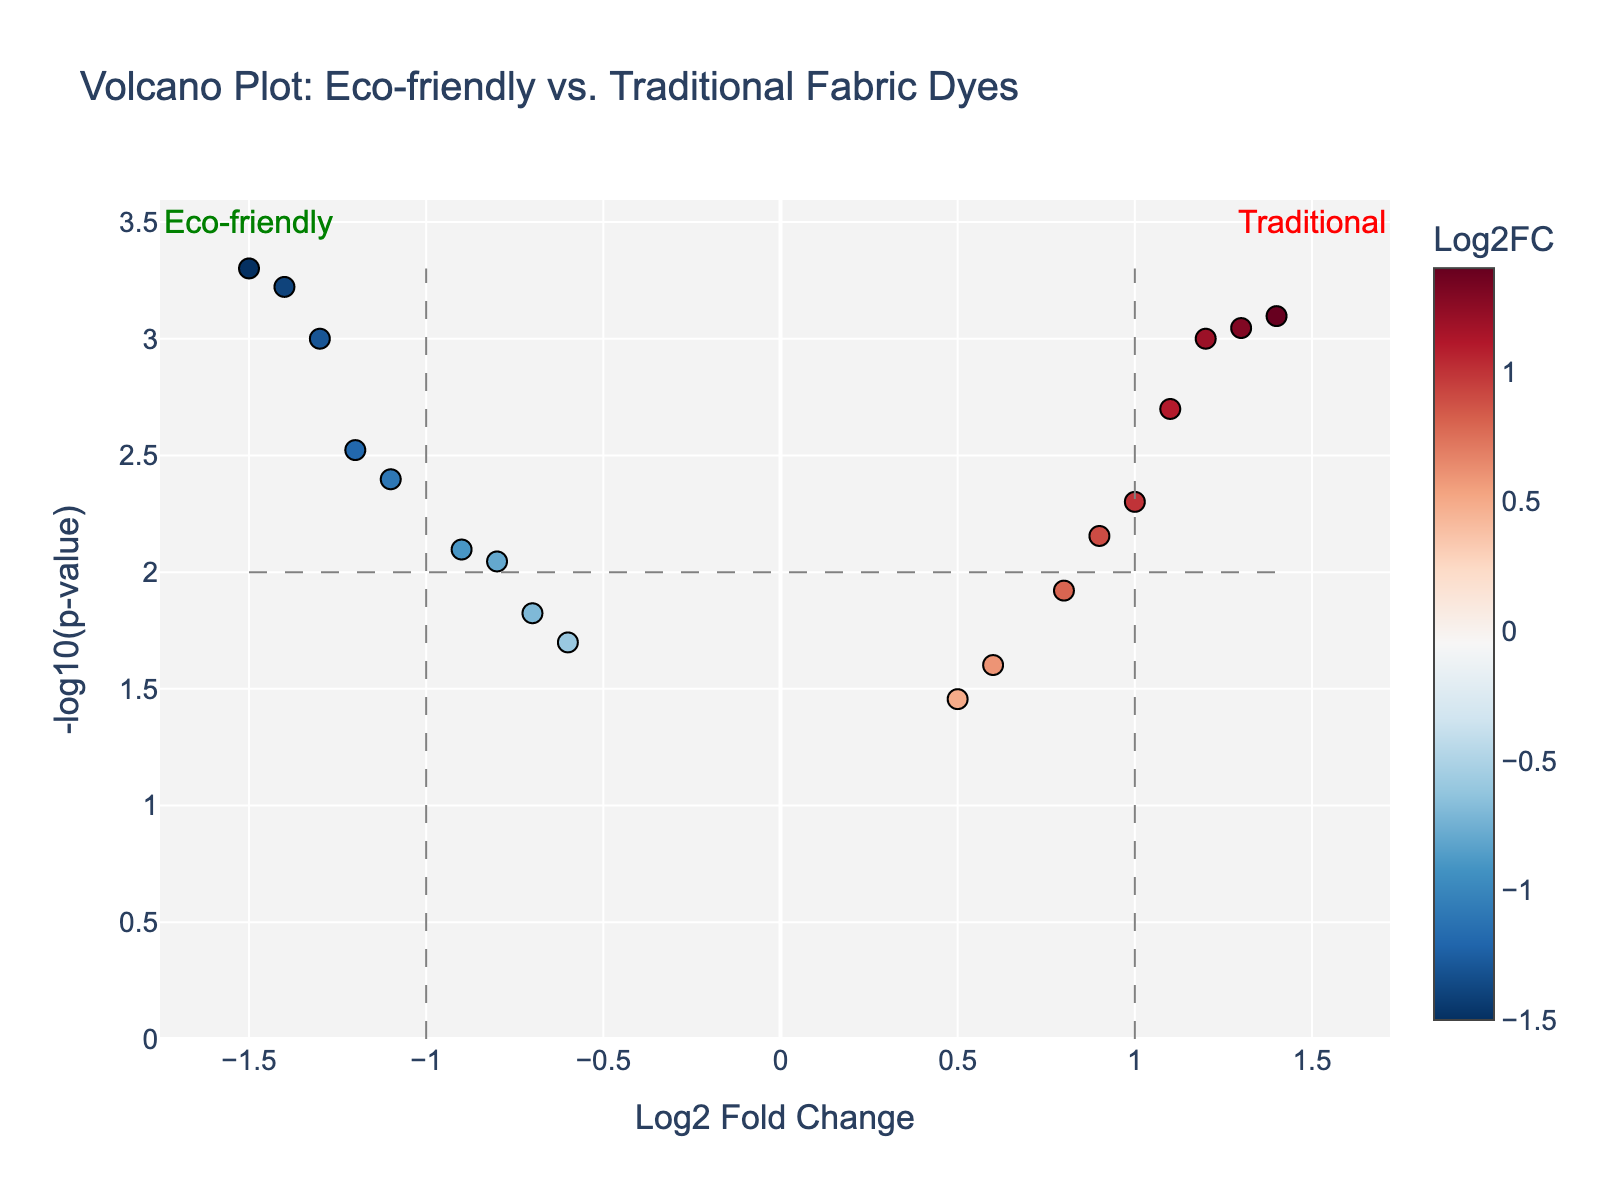How many total data points are displayed in the plot? Count the number of chemical names given in the data table. There are 18 chemicals listed, so there are 18 data points.
Answer: 18 What colors are used to represent the Log2 Fold Change on the plot? The plot uses a colorscale named 'RdBu_r,' which typically ranges from red to blue in reverse order. Therefore, the colors are reds for negative fold changes and blues for positive fold changes.
Answer: Red and blue Which chemical has the highest -log10(p-value)? Observing the y-axis values, Soy-based Dye shows the highest -log10(p-value).
Answer: Soy-based Dye Are there more eco-friendly or traditional dyes with significant p-values below 0.01? Eco-friendly dyes include Natural Indigo, Madder Root Extract, Turmeric Extract, Logwood Extract, Soy-based Dye, Chlorophyll Extract, Beetroot Extract, and Algae-based Dye. Traditional dyes include Synthetic Indigo, Alizarin, Cochineal, Carmine, Curcumin, Phthalocyanine, Hematein, Azo Dye, Reactive Dye, and Disperse Dye. Counting those with p-values below 0.01, we have 5 eco-friendly and 6 traditional dyes' p-values.
Answer: Traditional Which eco-friendly dye has the lowest log2 fold change and what is its value? Observing the x-axis values on the plot for eco-friendly dyes, Soy-based Dye has the lowest log2 fold change, which is -1.5.
Answer: Soy-based Dye, -1.5 What is the threshold for significant p-values indicated in the plot? The threshold can be found by identifying the horizontal dashed line, which is set at -log10(0.01) = 2.
Answer: 0.01 Which traditional dye is closest to the fold change threshold of ±1.0? By examining the x-axis values near ±1.0, the closest traditional dye is Reactive Dye with a log2 fold change of 1.0.
Answer: Reactive Dye How many eco-friendly dyes are above the fold change threshold of ±1.0? According to the log2 fold change values, the eco-friendly dyes with absolute fold changes greater than 1.0 are Turmeric Extract, Soy-based Dye, Chlorophyll Extract, and Algae-based Dye, so there are 4 in total.
Answer: 4 What does the position of the annotations 'Eco-friendly' and 'Traditional' in the plot signify? The annotations 'Eco-friendly' and 'Traditional' are placed at x = -1.5 and x = 1.5 respectively, suggesting that negative log2 fold changes are associated with eco-friendly dyes and positive log2 fold changes are associated with traditional dyes.
Answer: Eco-friendly on the left, Traditional on the right 